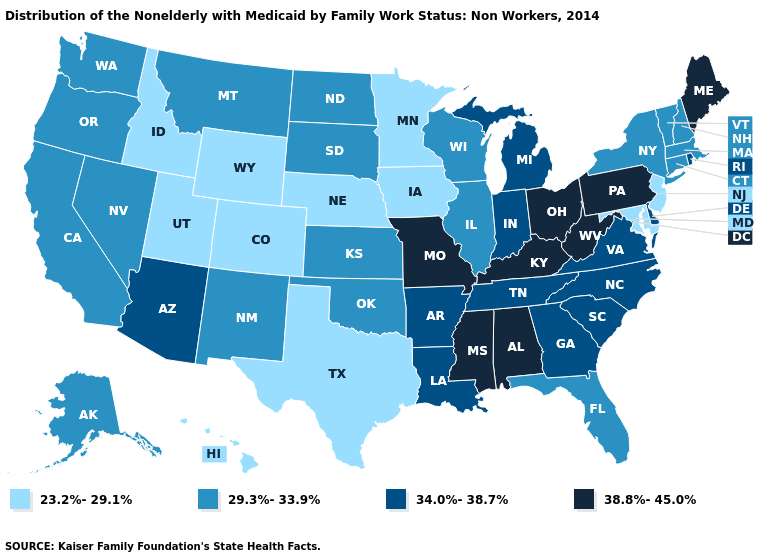Does Louisiana have a higher value than Florida?
Give a very brief answer. Yes. Does the first symbol in the legend represent the smallest category?
Answer briefly. Yes. How many symbols are there in the legend?
Answer briefly. 4. What is the value of Idaho?
Quick response, please. 23.2%-29.1%. What is the value of Alabama?
Answer briefly. 38.8%-45.0%. What is the value of Vermont?
Be succinct. 29.3%-33.9%. Which states have the lowest value in the West?
Be succinct. Colorado, Hawaii, Idaho, Utah, Wyoming. What is the value of Louisiana?
Answer briefly. 34.0%-38.7%. Which states hav the highest value in the Northeast?
Write a very short answer. Maine, Pennsylvania. What is the lowest value in the Northeast?
Give a very brief answer. 23.2%-29.1%. What is the value of Massachusetts?
Give a very brief answer. 29.3%-33.9%. Name the states that have a value in the range 34.0%-38.7%?
Write a very short answer. Arizona, Arkansas, Delaware, Georgia, Indiana, Louisiana, Michigan, North Carolina, Rhode Island, South Carolina, Tennessee, Virginia. What is the lowest value in the USA?
Keep it brief. 23.2%-29.1%. Name the states that have a value in the range 38.8%-45.0%?
Be succinct. Alabama, Kentucky, Maine, Mississippi, Missouri, Ohio, Pennsylvania, West Virginia. 